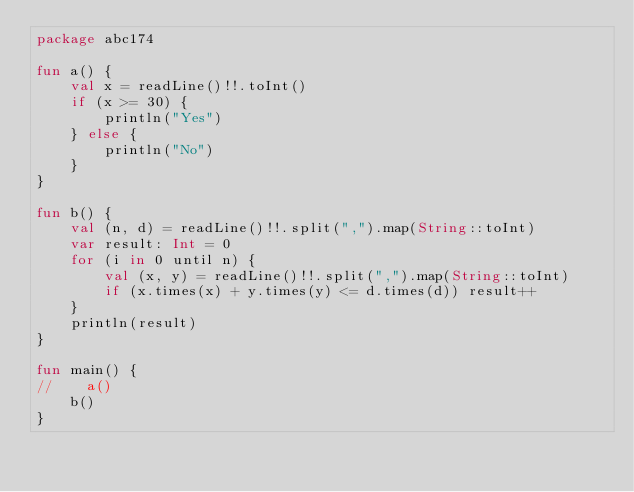<code> <loc_0><loc_0><loc_500><loc_500><_Kotlin_>package abc174

fun a() {
    val x = readLine()!!.toInt()
    if (x >= 30) {
        println("Yes")
    } else {
        println("No")
    }
}

fun b() {
    val (n, d) = readLine()!!.split(",").map(String::toInt)
    var result: Int = 0
    for (i in 0 until n) {
        val (x, y) = readLine()!!.split(",").map(String::toInt)
        if (x.times(x) + y.times(y) <= d.times(d)) result++
    }
    println(result)
}

fun main() {
//    a()
    b()
}</code> 